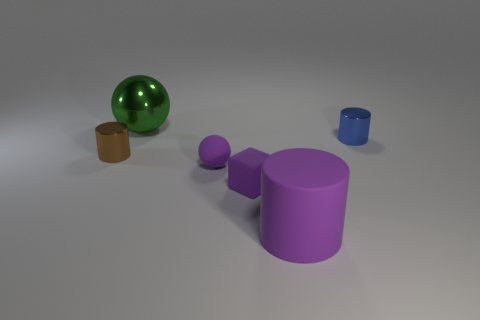Add 3 blue cylinders. How many objects exist? 9 Subtract all balls. How many objects are left? 4 Subtract all tiny blue metal objects. Subtract all small blue metallic cylinders. How many objects are left? 4 Add 4 tiny blue shiny cylinders. How many tiny blue shiny cylinders are left? 5 Add 1 rubber spheres. How many rubber spheres exist? 2 Subtract 1 purple cubes. How many objects are left? 5 